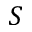<formula> <loc_0><loc_0><loc_500><loc_500>S</formula> 